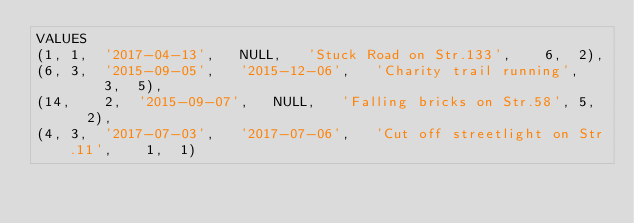<code> <loc_0><loc_0><loc_500><loc_500><_SQL_>VALUES
(1,	1,	'2017-04-13',	NULL,	'Stuck Road on Str.133',	6,	2),
(6,	3,	'2015-09-05',	'2015-12-06',	'Charity trail running',	3,	5),
(14,	2,	'2015-09-07',	NULL,	'Falling bricks on Str.58',	5,	2),
(4,	3,	'2017-07-03',	'2017-07-06',	'Cut off streetlight on Str.11',	1,	1)</code> 